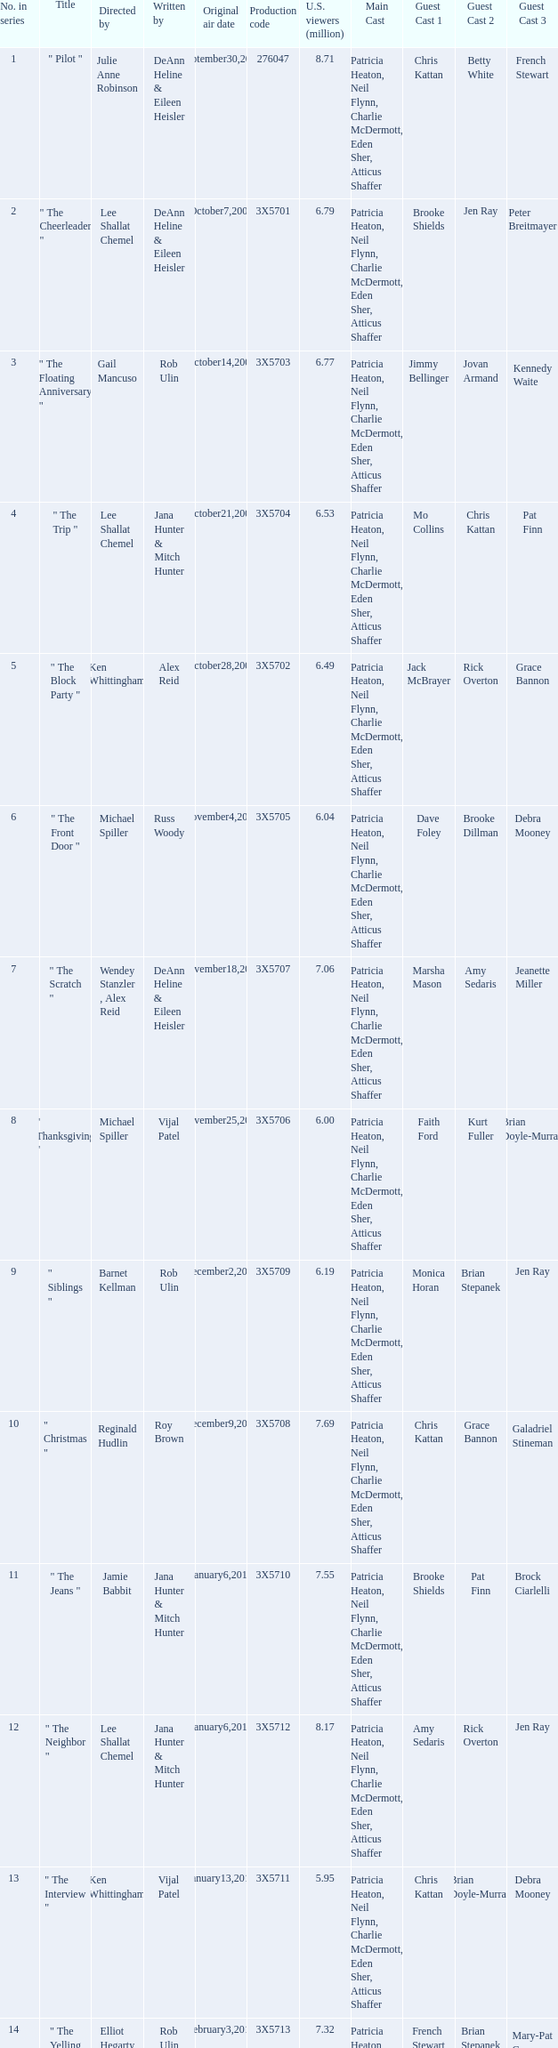How many million U.S. viewers saw the episode with production code 3X5710? 7.55. 